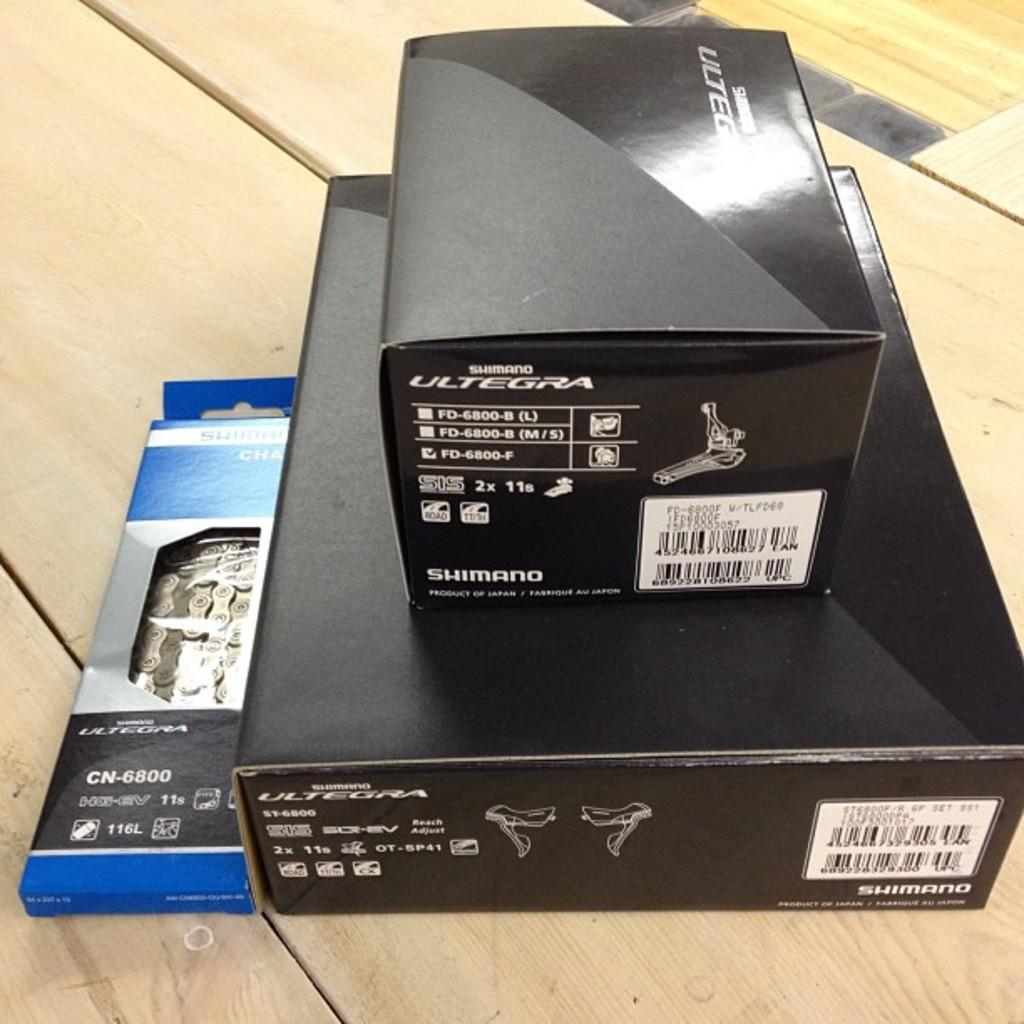<image>
Summarize the visual content of the image. A pile of Shimano bike parts sits on a wooden surface. 